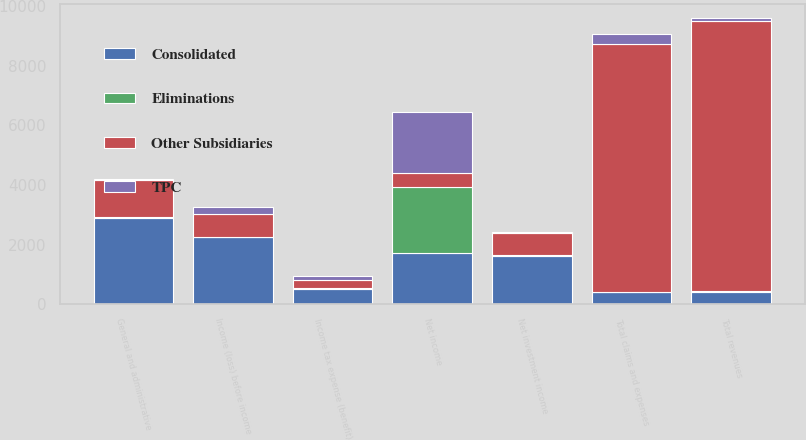Convert chart to OTSL. <chart><loc_0><loc_0><loc_500><loc_500><stacked_bar_chart><ecel><fcel>Net investment income<fcel>Total revenues<fcel>General and administrative<fcel>Total claims and expenses<fcel>Income (loss) before income<fcel>Income tax expense (benefit)<fcel>Net income<nl><fcel>Consolidated<fcel>1627<fcel>404<fcel>2906<fcel>404<fcel>2247<fcel>519<fcel>1728<nl><fcel>Other Subsidiaries<fcel>759<fcel>9079<fcel>1249<fcel>8327<fcel>752<fcel>290<fcel>462<nl><fcel>TPC<fcel>24<fcel>90<fcel>25<fcel>346<fcel>256<fcel>130<fcel>2064<nl><fcel>Eliminations<fcel>13<fcel>23<fcel>10<fcel>10<fcel>13<fcel>5<fcel>2198<nl></chart> 